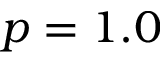Convert formula to latex. <formula><loc_0><loc_0><loc_500><loc_500>p = 1 . 0</formula> 